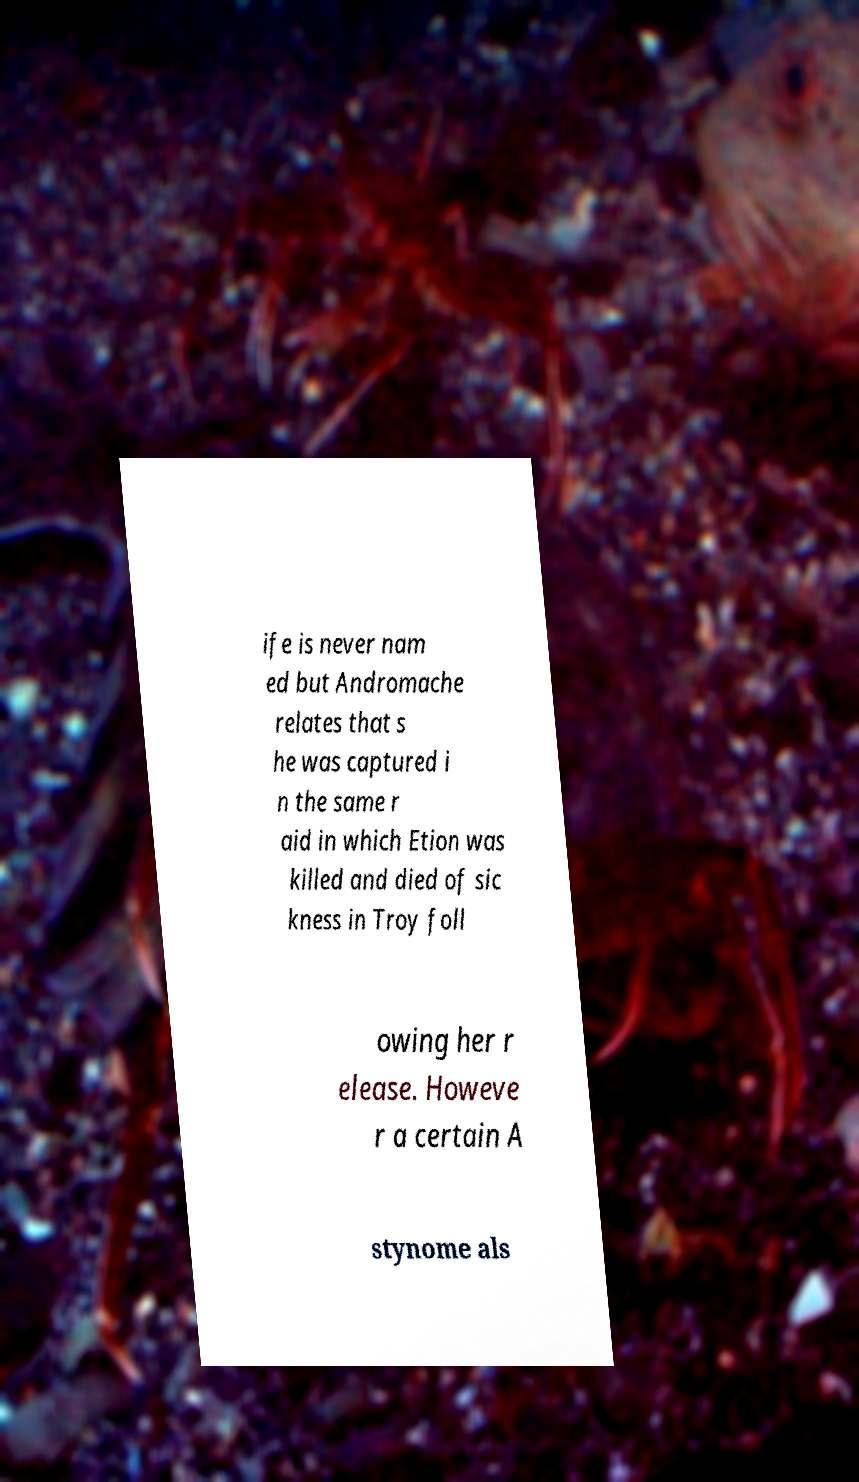Can you accurately transcribe the text from the provided image for me? ife is never nam ed but Andromache relates that s he was captured i n the same r aid in which Etion was killed and died of sic kness in Troy foll owing her r elease. Howeve r a certain A stynome als 